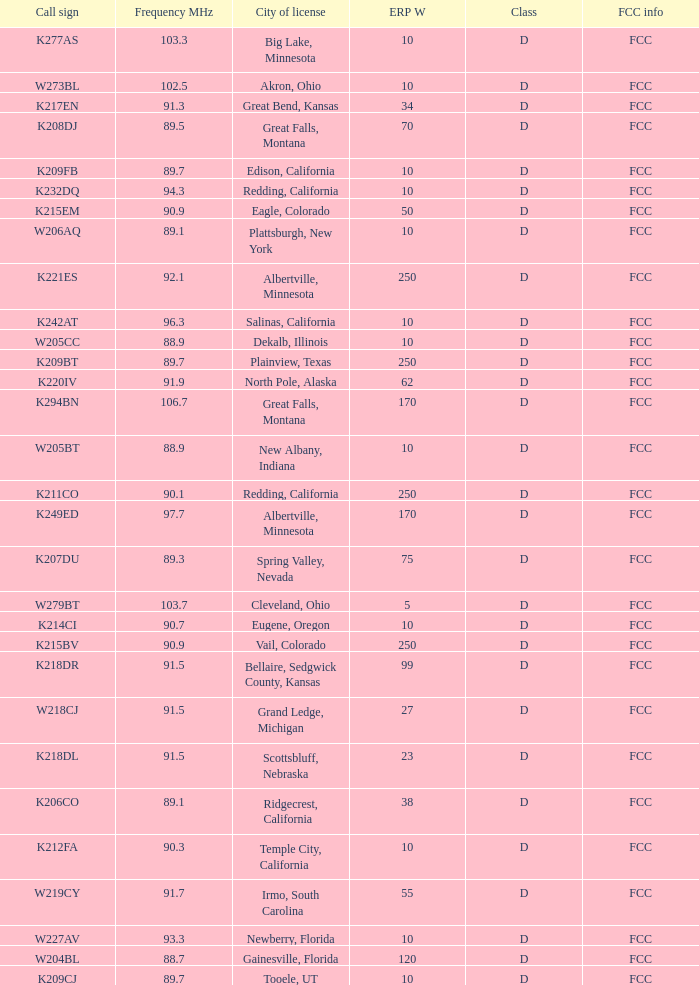What is the call sign of the translator with an ERP W greater than 38 and a city license from Great Falls, Montana? K294BN, K208DJ. 